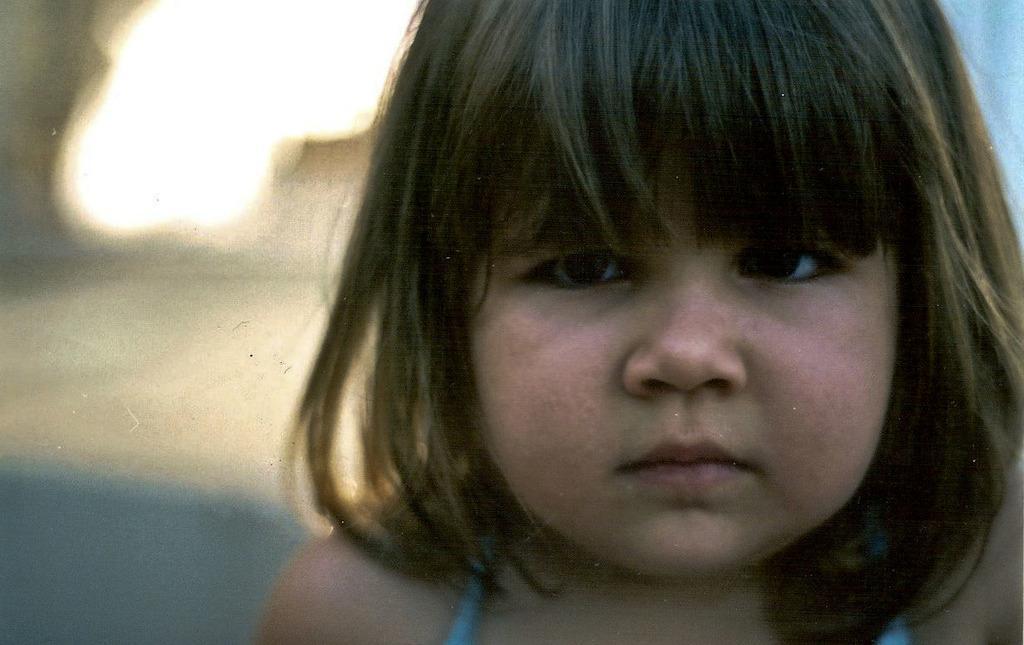Can you describe this image briefly? In this image I can see a girl. The background of the image is blurred. 